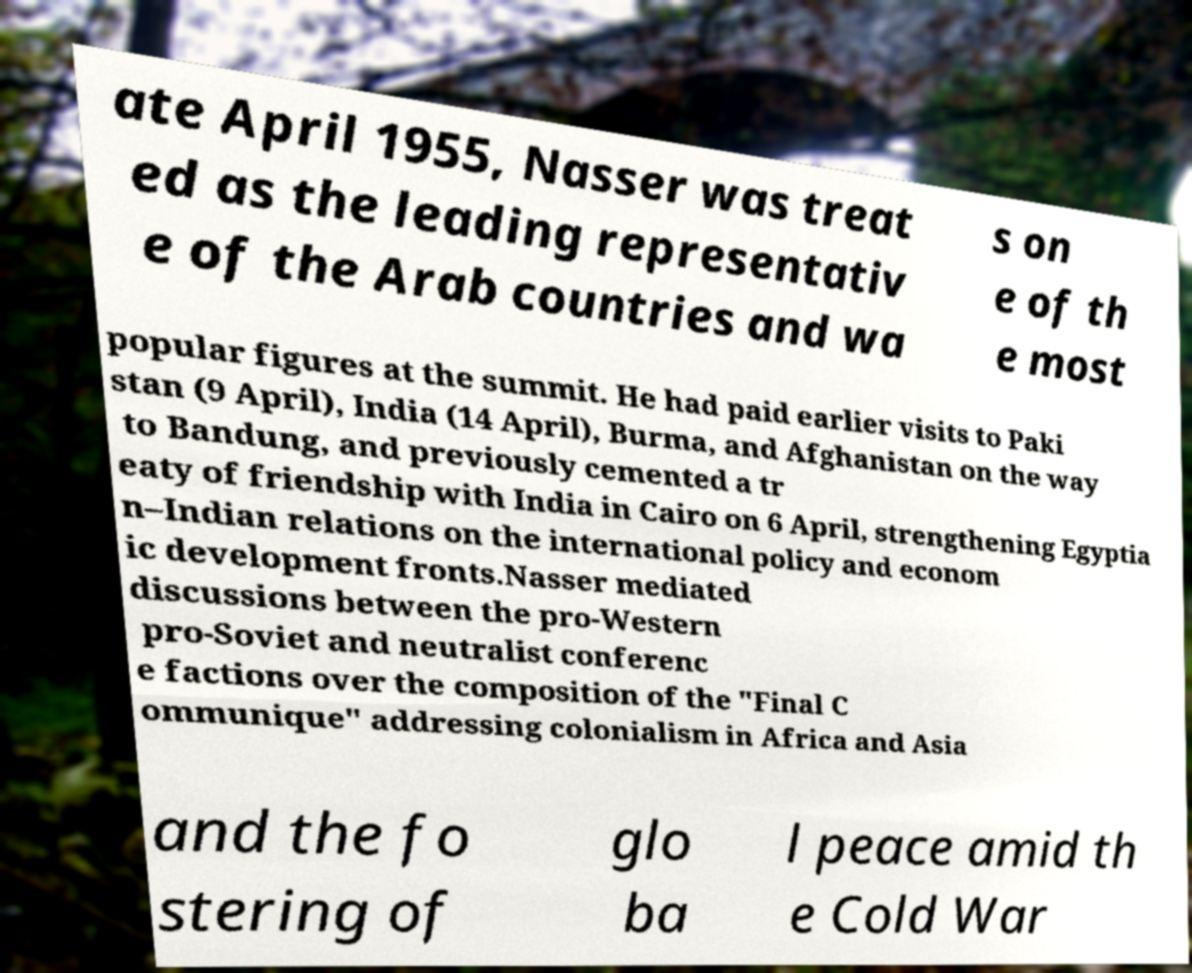Please identify and transcribe the text found in this image. ate April 1955, Nasser was treat ed as the leading representativ e of the Arab countries and wa s on e of th e most popular figures at the summit. He had paid earlier visits to Paki stan (9 April), India (14 April), Burma, and Afghanistan on the way to Bandung, and previously cemented a tr eaty of friendship with India in Cairo on 6 April, strengthening Egyptia n–Indian relations on the international policy and econom ic development fronts.Nasser mediated discussions between the pro-Western pro-Soviet and neutralist conferenc e factions over the composition of the "Final C ommunique" addressing colonialism in Africa and Asia and the fo stering of glo ba l peace amid th e Cold War 